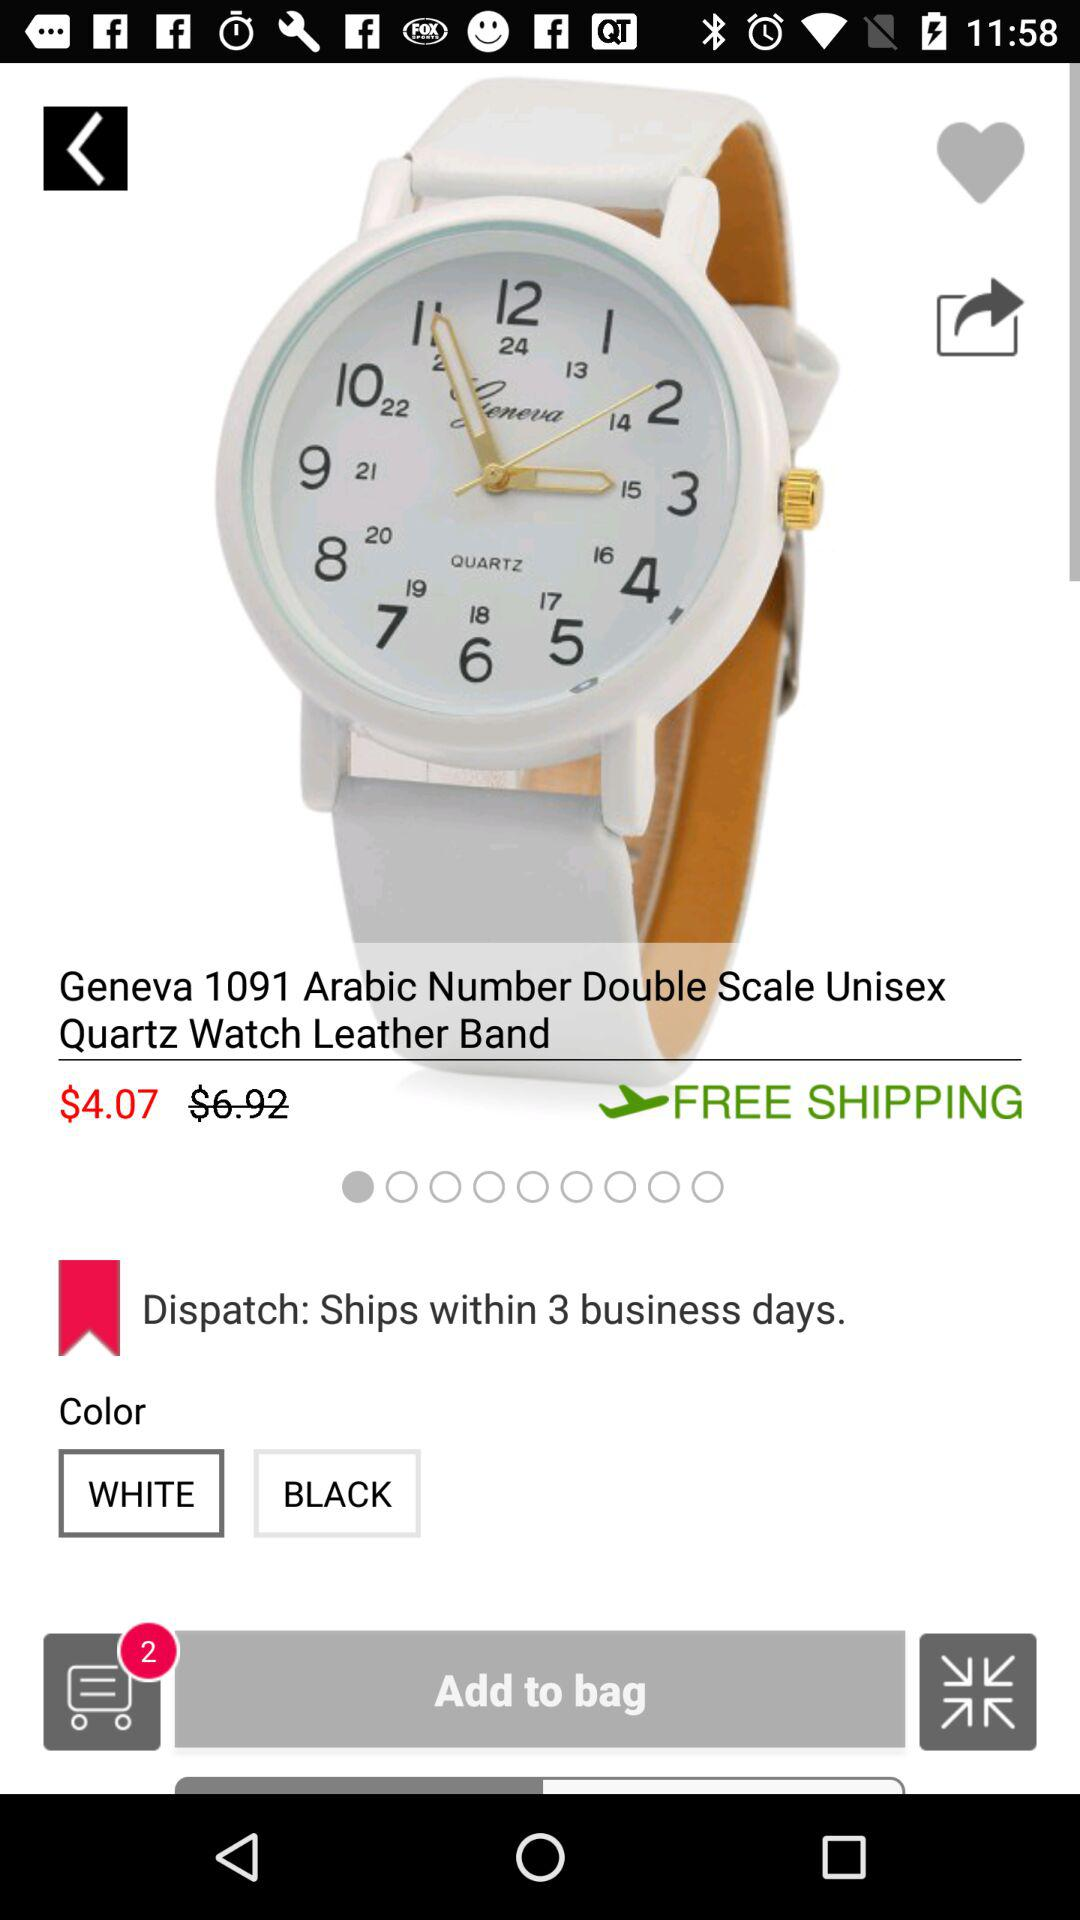How many items are in the cart? There are 2 items in the cart. 